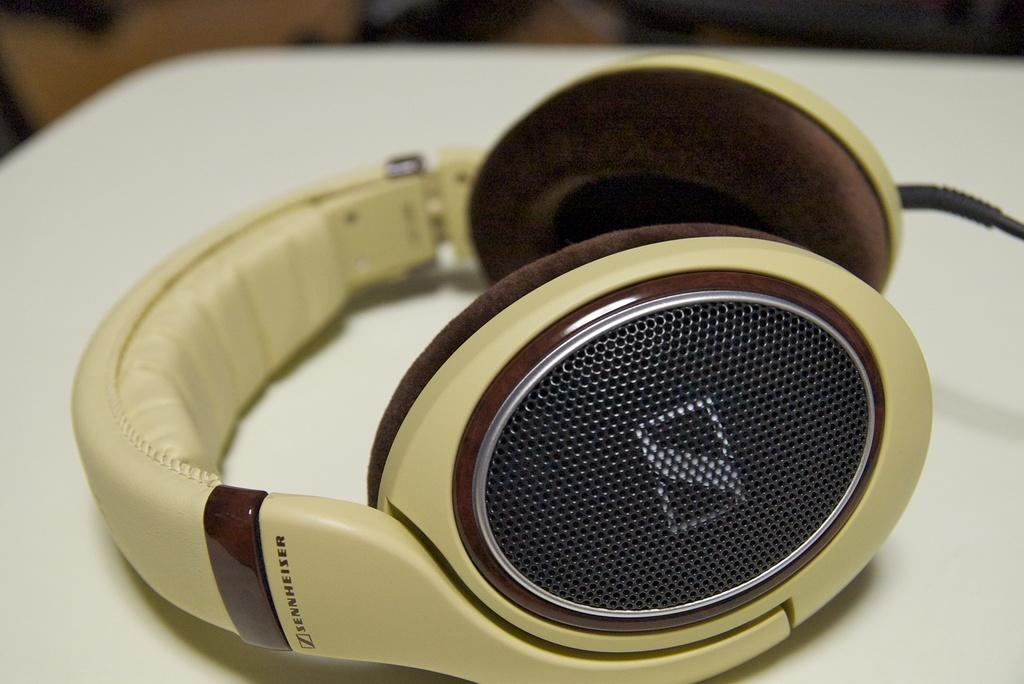What is the main object in the foreground of the image? There is a headphone in the foreground of the image. Can you describe the setting of the image? The image may have been taken in a room. What type of stew is being prepared in the image? There is no stew present in the image; it features a headphone in the foreground. What color is the marble in the image? There is no marble present in the image. 